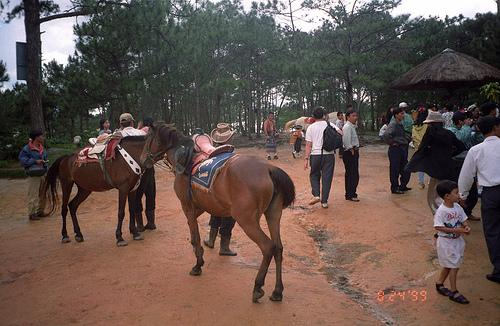Based on the image, what type of event or gathering might be taking place? The image could represent a casual gathering or event involving horses and people, possibly in an outdoor rural setting. If this image were to be used for a product advertisement, what type of product could be promoted? The image could be used to promote horse-riding equipment, outdoor clothing and gear, or eco-friendly travel and tour services in rural areas. What are some elements in the image related to nature and the environment? Tall green trees, needles of pine trees, thatched roof, cloud cover, red clay ground, a small stream, and green treeline are environmental elements present in the image. Identify three things associated with horses in this image. Red saddle on a blue blanket, wagging tail of a horse, and four legs of a horse can be observed in the image. Briefly describe the attire and accessories worn by the people in the image. A man is wearing a hat and carrying a black backpack while standing next to a horse, a child wearing white shorts and sandals is seen walking, and a person with a tan hat can also be spotted. What can be said about the landscape and environment in the image? The image shows a crowd of people and horses gathered on a red clay ground, with tall green trees and a straw hut in the background, and a small stream of water flowing through the dirt. For the visual entailment task, can you conclude that there are horses present in this image? Yes, the presence of a brown horse, two standing brown horses, and various horse-related elements support the conclusion that horses are present in the image. 